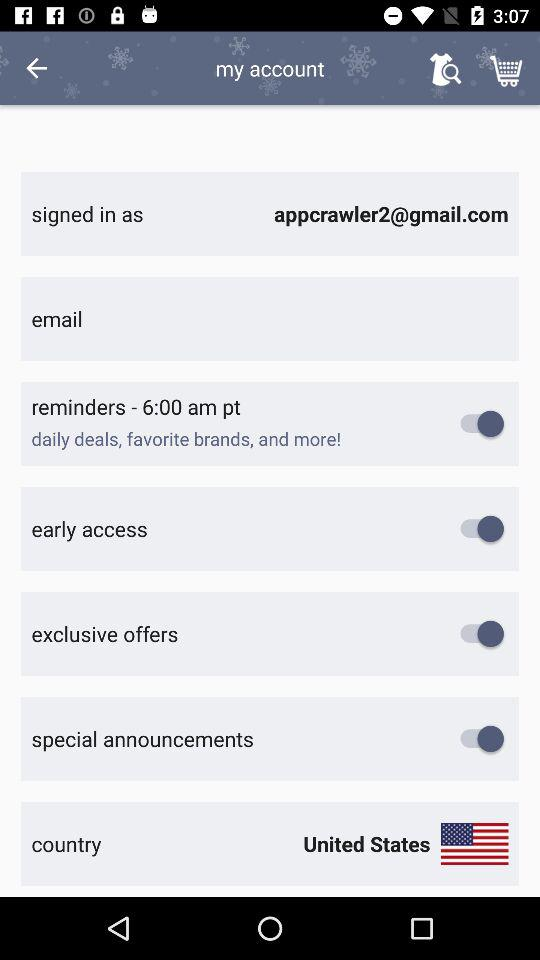What's the country? The country is the United States. 